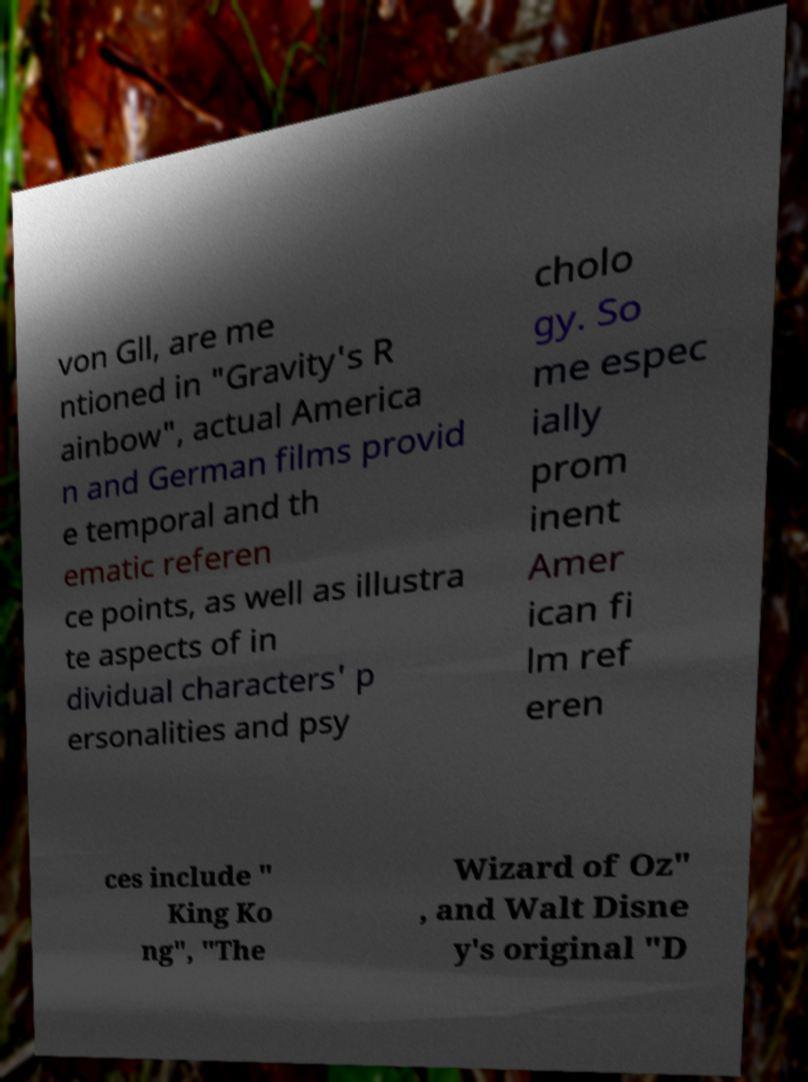There's text embedded in this image that I need extracted. Can you transcribe it verbatim? von Gll, are me ntioned in "Gravity's R ainbow", actual America n and German films provid e temporal and th ematic referen ce points, as well as illustra te aspects of in dividual characters' p ersonalities and psy cholo gy. So me espec ially prom inent Amer ican fi lm ref eren ces include " King Ko ng", "The Wizard of Oz" , and Walt Disne y's original "D 